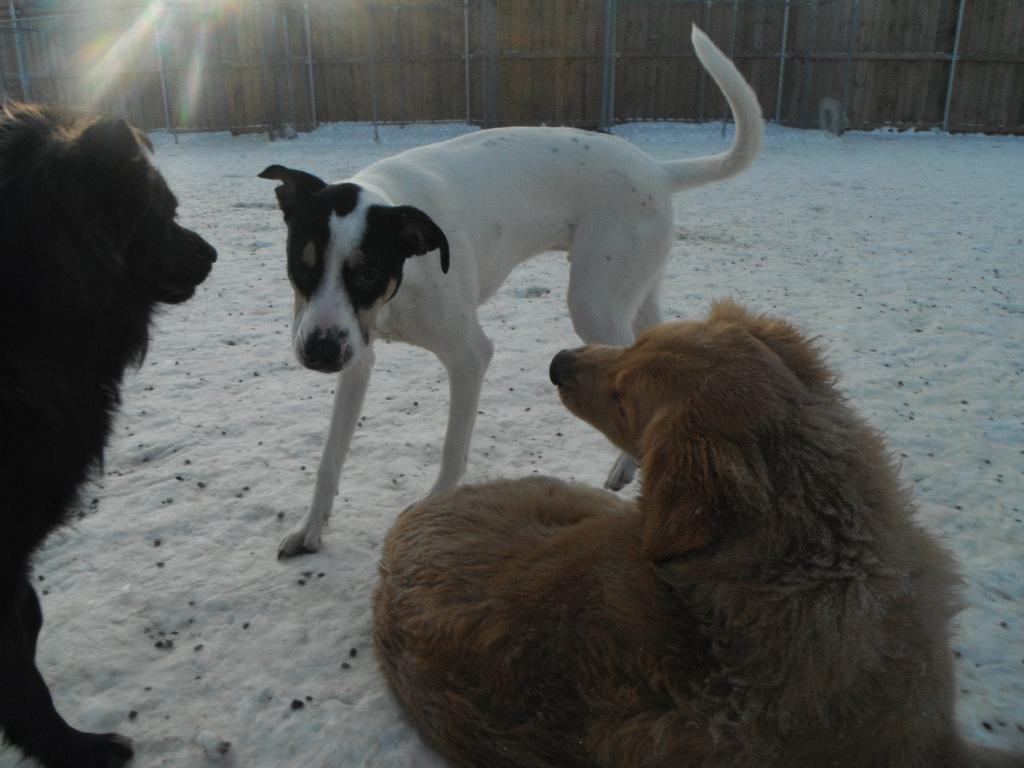How many dogs are present in the image? There are three dogs in the image. What is the surface on which the dogs are standing? The dogs are on the surface of the snow. What can be seen in the background of the image? There is a wooden wall in the background of the image. How many legs does each spider have in the image? There are no spiders present in the image, so it is not possible to determine the number of legs each spider might have. 